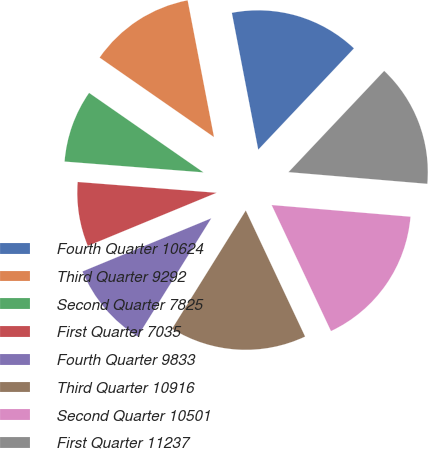<chart> <loc_0><loc_0><loc_500><loc_500><pie_chart><fcel>Fourth Quarter 10624<fcel>Third Quarter 9292<fcel>Second Quarter 7825<fcel>First Quarter 7035<fcel>Fourth Quarter 9833<fcel>Third Quarter 10916<fcel>Second Quarter 10501<fcel>First Quarter 11237<nl><fcel>15.08%<fcel>12.3%<fcel>8.43%<fcel>7.47%<fcel>9.9%<fcel>15.87%<fcel>16.66%<fcel>14.29%<nl></chart> 